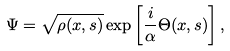<formula> <loc_0><loc_0><loc_500><loc_500>\Psi = \sqrt { \rho ( x , s ) } \exp \left [ { \frac { i } { \alpha } } \Theta ( x , s ) \right ] ,</formula> 